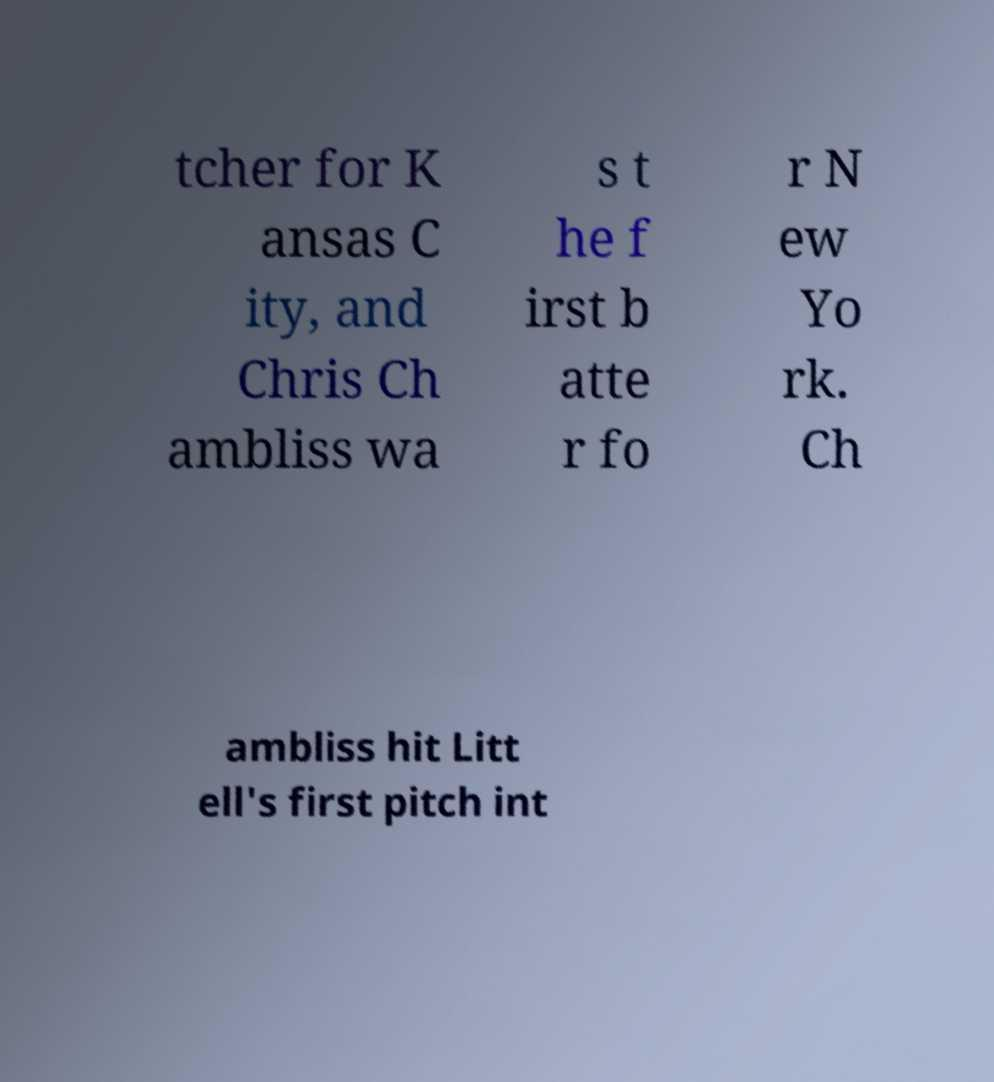Please identify and transcribe the text found in this image. tcher for K ansas C ity, and Chris Ch ambliss wa s t he f irst b atte r fo r N ew Yo rk. Ch ambliss hit Litt ell's first pitch int 